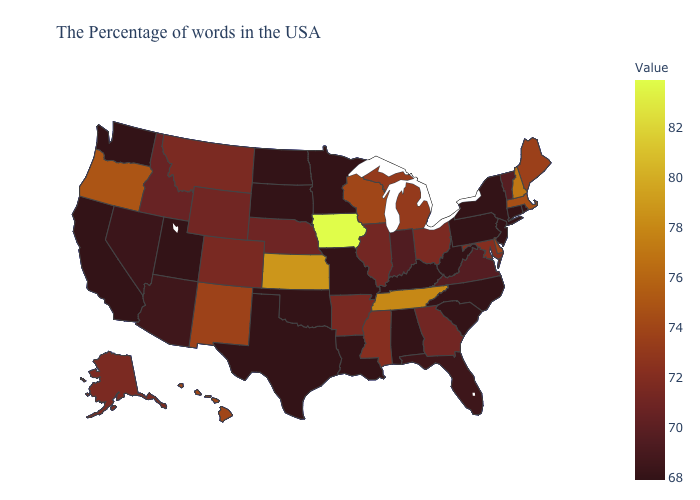Does New Hampshire have the lowest value in the USA?
Quick response, please. No. Among the states that border North Dakota , which have the lowest value?
Give a very brief answer. Minnesota, South Dakota. Does Illinois have the lowest value in the MidWest?
Concise answer only. No. 